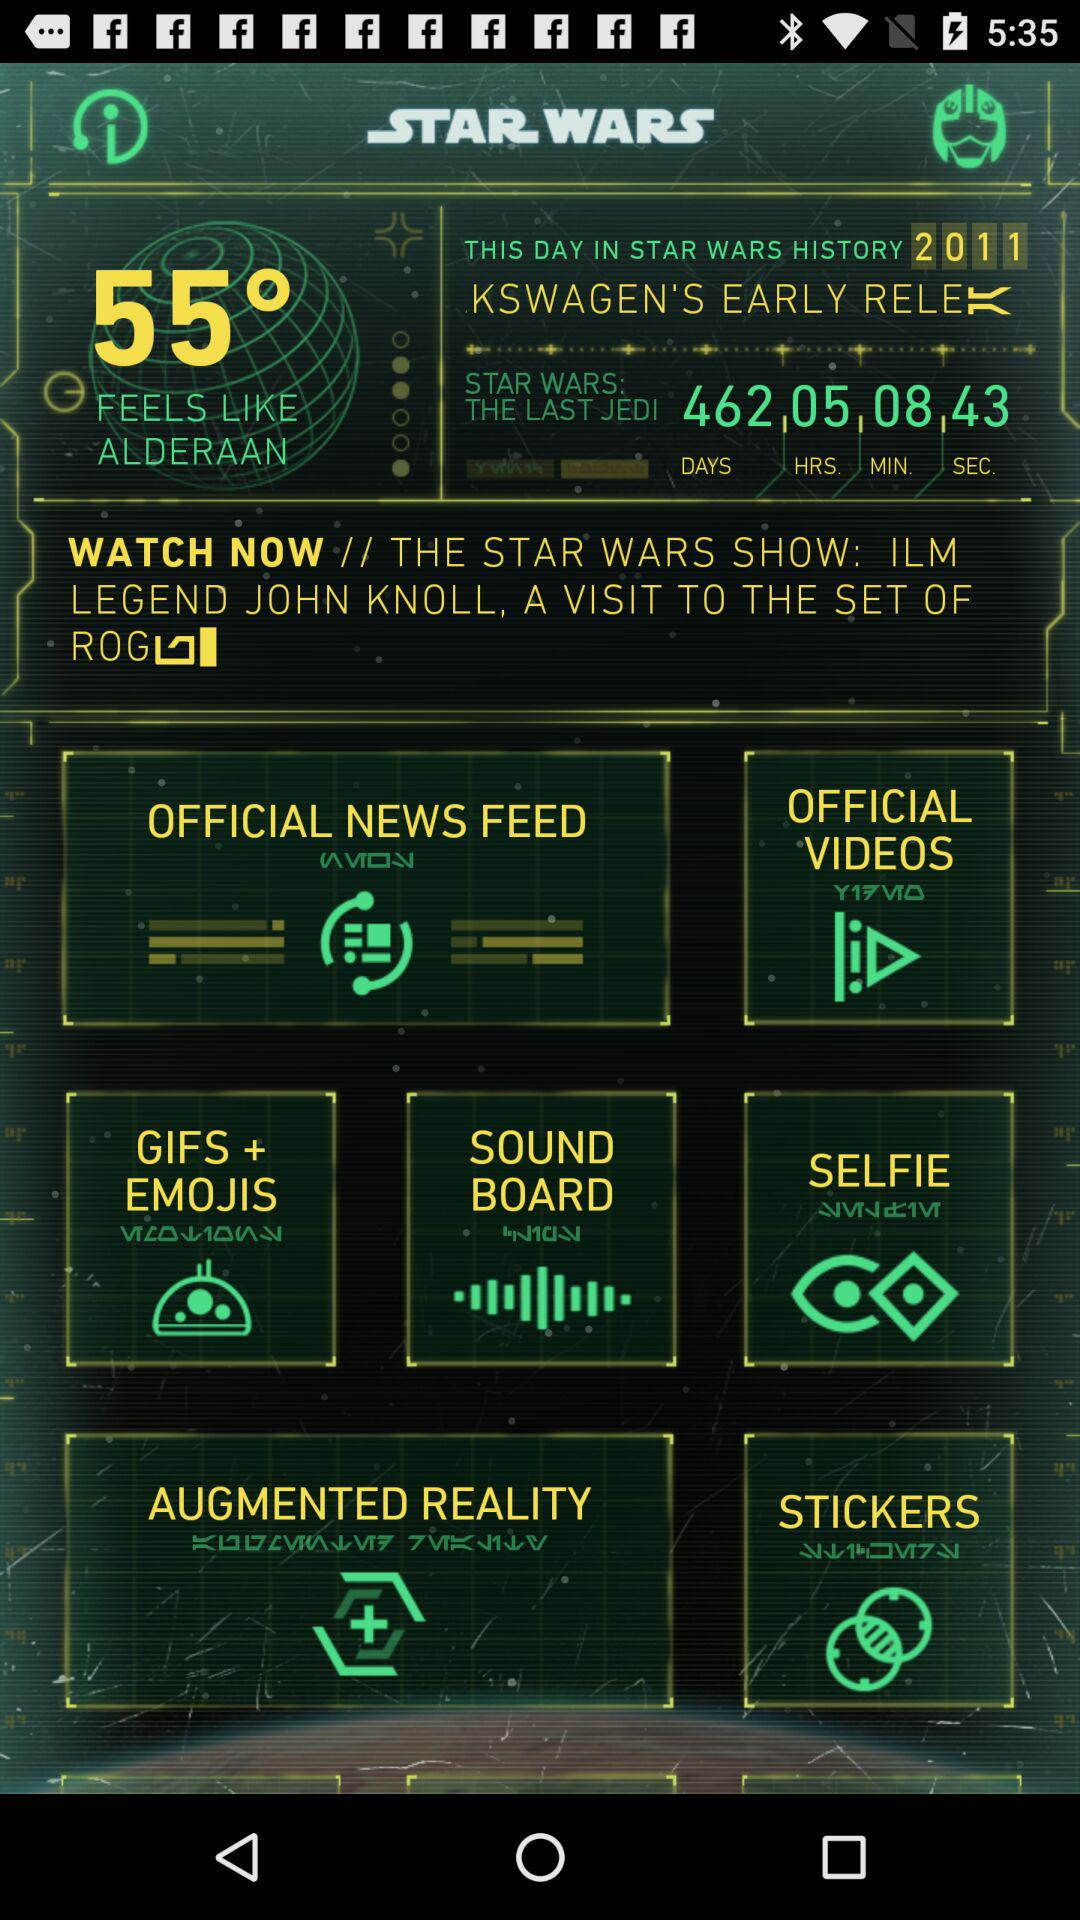How much time remains for "STAR WARS: THE LAST JEDI"? The remaining time is 462 days, 5 hours, 8 minutes, and 43 seconds. 